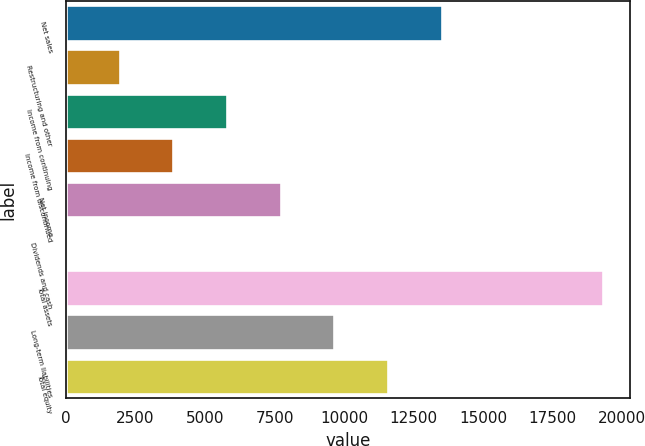Convert chart. <chart><loc_0><loc_0><loc_500><loc_500><bar_chart><fcel>Net sales<fcel>Restructuring and other<fcel>Income from continuing<fcel>Income from discontinued<fcel>Net income<fcel>Dividends and cash<fcel>Total assets<fcel>Long-term liabilities<fcel>Total equity<nl><fcel>13514.4<fcel>1931.3<fcel>5792.34<fcel>3861.82<fcel>7722.86<fcel>0.78<fcel>19306<fcel>9653.38<fcel>11583.9<nl></chart> 